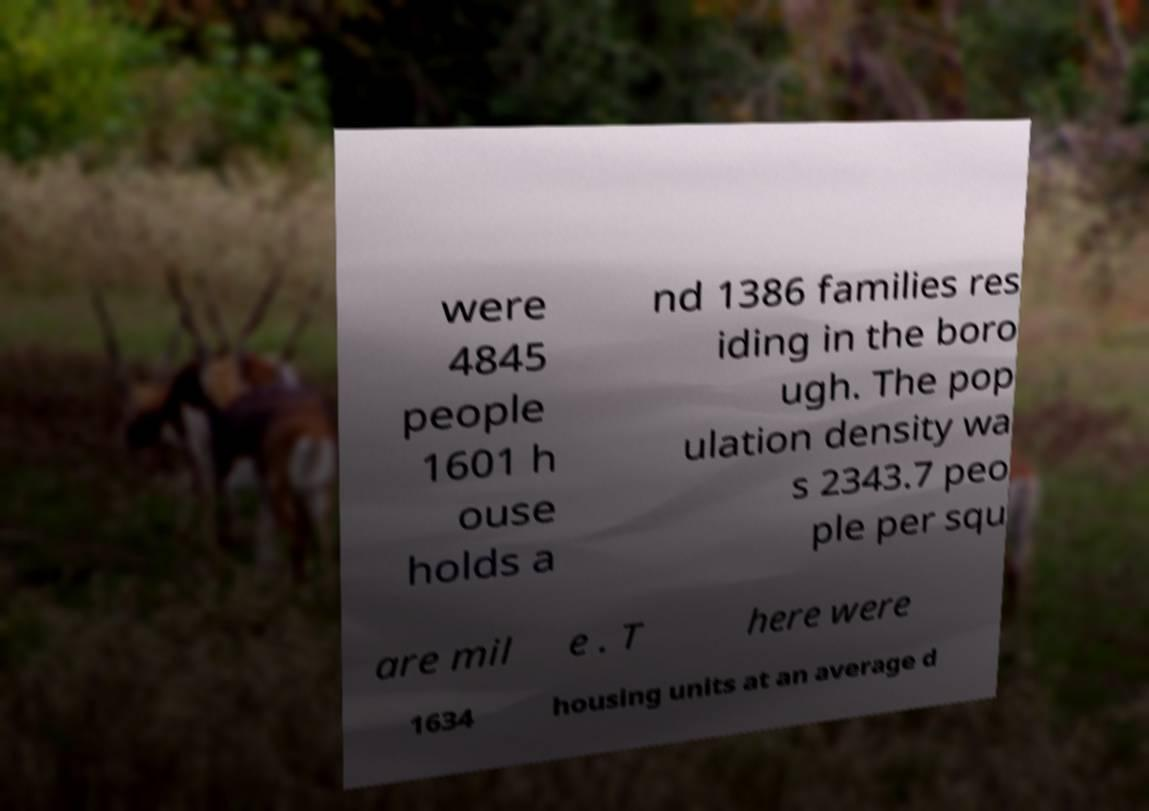There's text embedded in this image that I need extracted. Can you transcribe it verbatim? were 4845 people 1601 h ouse holds a nd 1386 families res iding in the boro ugh. The pop ulation density wa s 2343.7 peo ple per squ are mil e . T here were 1634 housing units at an average d 